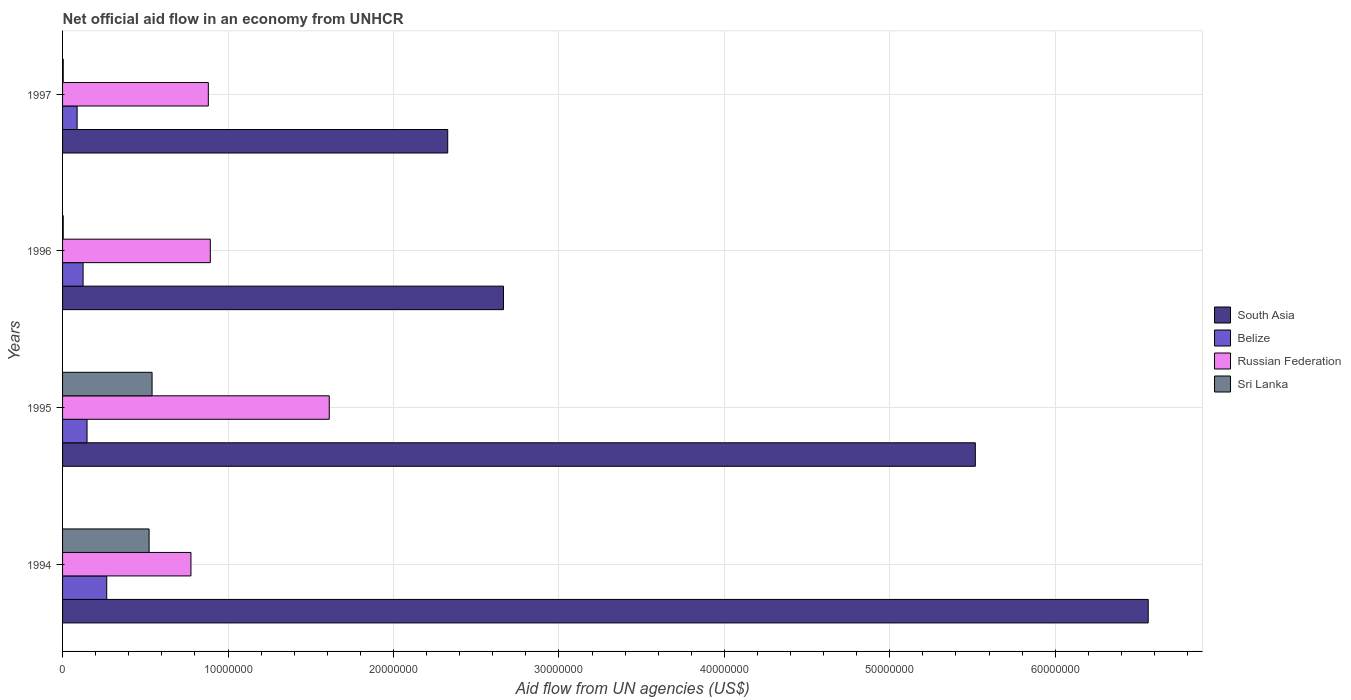How many groups of bars are there?
Your answer should be compact. 4. Are the number of bars per tick equal to the number of legend labels?
Keep it short and to the point. Yes. Are the number of bars on each tick of the Y-axis equal?
Provide a short and direct response. Yes. How many bars are there on the 3rd tick from the top?
Offer a very short reply. 4. How many bars are there on the 1st tick from the bottom?
Provide a succinct answer. 4. In how many cases, is the number of bars for a given year not equal to the number of legend labels?
Your answer should be compact. 0. What is the net official aid flow in Belize in 1995?
Your answer should be compact. 1.48e+06. Across all years, what is the maximum net official aid flow in Belize?
Make the answer very short. 2.67e+06. Across all years, what is the minimum net official aid flow in South Asia?
Provide a succinct answer. 2.33e+07. In which year was the net official aid flow in Russian Federation minimum?
Offer a terse response. 1994. What is the total net official aid flow in Russian Federation in the graph?
Offer a very short reply. 4.16e+07. What is the difference between the net official aid flow in Belize in 1994 and that in 1995?
Your answer should be very brief. 1.19e+06. What is the difference between the net official aid flow in Belize in 1994 and the net official aid flow in South Asia in 1996?
Make the answer very short. -2.40e+07. What is the average net official aid flow in Russian Federation per year?
Your response must be concise. 1.04e+07. In the year 1996, what is the difference between the net official aid flow in Sri Lanka and net official aid flow in Belize?
Offer a terse response. -1.20e+06. In how many years, is the net official aid flow in South Asia greater than 44000000 US$?
Ensure brevity in your answer.  2. What is the ratio of the net official aid flow in South Asia in 1994 to that in 1997?
Provide a succinct answer. 2.82. Is the net official aid flow in Belize in 1994 less than that in 1995?
Ensure brevity in your answer.  No. Is the difference between the net official aid flow in Sri Lanka in 1995 and 1996 greater than the difference between the net official aid flow in Belize in 1995 and 1996?
Offer a terse response. Yes. What is the difference between the highest and the second highest net official aid flow in Sri Lanka?
Give a very brief answer. 1.80e+05. What is the difference between the highest and the lowest net official aid flow in Belize?
Your answer should be very brief. 1.79e+06. In how many years, is the net official aid flow in Belize greater than the average net official aid flow in Belize taken over all years?
Your answer should be very brief. 1. What does the 4th bar from the top in 1995 represents?
Offer a very short reply. South Asia. How many bars are there?
Your response must be concise. 16. Are the values on the major ticks of X-axis written in scientific E-notation?
Provide a short and direct response. No. Does the graph contain grids?
Offer a very short reply. Yes. Where does the legend appear in the graph?
Give a very brief answer. Center right. How many legend labels are there?
Give a very brief answer. 4. How are the legend labels stacked?
Give a very brief answer. Vertical. What is the title of the graph?
Provide a short and direct response. Net official aid flow in an economy from UNHCR. Does "Iceland" appear as one of the legend labels in the graph?
Offer a terse response. No. What is the label or title of the X-axis?
Keep it short and to the point. Aid flow from UN agencies (US$). What is the label or title of the Y-axis?
Offer a very short reply. Years. What is the Aid flow from UN agencies (US$) in South Asia in 1994?
Your answer should be compact. 6.56e+07. What is the Aid flow from UN agencies (US$) in Belize in 1994?
Give a very brief answer. 2.67e+06. What is the Aid flow from UN agencies (US$) in Russian Federation in 1994?
Offer a very short reply. 7.76e+06. What is the Aid flow from UN agencies (US$) in Sri Lanka in 1994?
Your answer should be compact. 5.23e+06. What is the Aid flow from UN agencies (US$) in South Asia in 1995?
Ensure brevity in your answer.  5.52e+07. What is the Aid flow from UN agencies (US$) in Belize in 1995?
Offer a terse response. 1.48e+06. What is the Aid flow from UN agencies (US$) of Russian Federation in 1995?
Give a very brief answer. 1.61e+07. What is the Aid flow from UN agencies (US$) in Sri Lanka in 1995?
Give a very brief answer. 5.41e+06. What is the Aid flow from UN agencies (US$) in South Asia in 1996?
Give a very brief answer. 2.66e+07. What is the Aid flow from UN agencies (US$) in Belize in 1996?
Your answer should be very brief. 1.24e+06. What is the Aid flow from UN agencies (US$) in Russian Federation in 1996?
Offer a very short reply. 8.93e+06. What is the Aid flow from UN agencies (US$) in Sri Lanka in 1996?
Keep it short and to the point. 4.00e+04. What is the Aid flow from UN agencies (US$) of South Asia in 1997?
Give a very brief answer. 2.33e+07. What is the Aid flow from UN agencies (US$) in Belize in 1997?
Your answer should be very brief. 8.80e+05. What is the Aid flow from UN agencies (US$) of Russian Federation in 1997?
Your answer should be compact. 8.81e+06. What is the Aid flow from UN agencies (US$) of Sri Lanka in 1997?
Ensure brevity in your answer.  4.00e+04. Across all years, what is the maximum Aid flow from UN agencies (US$) of South Asia?
Keep it short and to the point. 6.56e+07. Across all years, what is the maximum Aid flow from UN agencies (US$) in Belize?
Your response must be concise. 2.67e+06. Across all years, what is the maximum Aid flow from UN agencies (US$) in Russian Federation?
Keep it short and to the point. 1.61e+07. Across all years, what is the maximum Aid flow from UN agencies (US$) of Sri Lanka?
Your answer should be compact. 5.41e+06. Across all years, what is the minimum Aid flow from UN agencies (US$) of South Asia?
Provide a short and direct response. 2.33e+07. Across all years, what is the minimum Aid flow from UN agencies (US$) of Belize?
Your answer should be very brief. 8.80e+05. Across all years, what is the minimum Aid flow from UN agencies (US$) in Russian Federation?
Offer a terse response. 7.76e+06. Across all years, what is the minimum Aid flow from UN agencies (US$) in Sri Lanka?
Your response must be concise. 4.00e+04. What is the total Aid flow from UN agencies (US$) of South Asia in the graph?
Ensure brevity in your answer.  1.71e+08. What is the total Aid flow from UN agencies (US$) of Belize in the graph?
Keep it short and to the point. 6.27e+06. What is the total Aid flow from UN agencies (US$) of Russian Federation in the graph?
Your response must be concise. 4.16e+07. What is the total Aid flow from UN agencies (US$) of Sri Lanka in the graph?
Provide a succinct answer. 1.07e+07. What is the difference between the Aid flow from UN agencies (US$) in South Asia in 1994 and that in 1995?
Ensure brevity in your answer.  1.04e+07. What is the difference between the Aid flow from UN agencies (US$) in Belize in 1994 and that in 1995?
Make the answer very short. 1.19e+06. What is the difference between the Aid flow from UN agencies (US$) of Russian Federation in 1994 and that in 1995?
Give a very brief answer. -8.36e+06. What is the difference between the Aid flow from UN agencies (US$) of Sri Lanka in 1994 and that in 1995?
Your answer should be very brief. -1.80e+05. What is the difference between the Aid flow from UN agencies (US$) in South Asia in 1994 and that in 1996?
Your response must be concise. 3.90e+07. What is the difference between the Aid flow from UN agencies (US$) of Belize in 1994 and that in 1996?
Your answer should be compact. 1.43e+06. What is the difference between the Aid flow from UN agencies (US$) of Russian Federation in 1994 and that in 1996?
Your answer should be compact. -1.17e+06. What is the difference between the Aid flow from UN agencies (US$) of Sri Lanka in 1994 and that in 1996?
Your answer should be compact. 5.19e+06. What is the difference between the Aid flow from UN agencies (US$) of South Asia in 1994 and that in 1997?
Ensure brevity in your answer.  4.23e+07. What is the difference between the Aid flow from UN agencies (US$) in Belize in 1994 and that in 1997?
Ensure brevity in your answer.  1.79e+06. What is the difference between the Aid flow from UN agencies (US$) of Russian Federation in 1994 and that in 1997?
Provide a short and direct response. -1.05e+06. What is the difference between the Aid flow from UN agencies (US$) in Sri Lanka in 1994 and that in 1997?
Offer a very short reply. 5.19e+06. What is the difference between the Aid flow from UN agencies (US$) of South Asia in 1995 and that in 1996?
Your answer should be very brief. 2.85e+07. What is the difference between the Aid flow from UN agencies (US$) in Belize in 1995 and that in 1996?
Your answer should be compact. 2.40e+05. What is the difference between the Aid flow from UN agencies (US$) in Russian Federation in 1995 and that in 1996?
Offer a terse response. 7.19e+06. What is the difference between the Aid flow from UN agencies (US$) in Sri Lanka in 1995 and that in 1996?
Provide a short and direct response. 5.37e+06. What is the difference between the Aid flow from UN agencies (US$) in South Asia in 1995 and that in 1997?
Offer a very short reply. 3.19e+07. What is the difference between the Aid flow from UN agencies (US$) of Belize in 1995 and that in 1997?
Provide a short and direct response. 6.00e+05. What is the difference between the Aid flow from UN agencies (US$) in Russian Federation in 1995 and that in 1997?
Your answer should be very brief. 7.31e+06. What is the difference between the Aid flow from UN agencies (US$) in Sri Lanka in 1995 and that in 1997?
Ensure brevity in your answer.  5.37e+06. What is the difference between the Aid flow from UN agencies (US$) of South Asia in 1996 and that in 1997?
Make the answer very short. 3.37e+06. What is the difference between the Aid flow from UN agencies (US$) of Russian Federation in 1996 and that in 1997?
Ensure brevity in your answer.  1.20e+05. What is the difference between the Aid flow from UN agencies (US$) in South Asia in 1994 and the Aid flow from UN agencies (US$) in Belize in 1995?
Ensure brevity in your answer.  6.41e+07. What is the difference between the Aid flow from UN agencies (US$) of South Asia in 1994 and the Aid flow from UN agencies (US$) of Russian Federation in 1995?
Your answer should be very brief. 4.95e+07. What is the difference between the Aid flow from UN agencies (US$) of South Asia in 1994 and the Aid flow from UN agencies (US$) of Sri Lanka in 1995?
Offer a very short reply. 6.02e+07. What is the difference between the Aid flow from UN agencies (US$) in Belize in 1994 and the Aid flow from UN agencies (US$) in Russian Federation in 1995?
Make the answer very short. -1.34e+07. What is the difference between the Aid flow from UN agencies (US$) of Belize in 1994 and the Aid flow from UN agencies (US$) of Sri Lanka in 1995?
Your answer should be compact. -2.74e+06. What is the difference between the Aid flow from UN agencies (US$) of Russian Federation in 1994 and the Aid flow from UN agencies (US$) of Sri Lanka in 1995?
Ensure brevity in your answer.  2.35e+06. What is the difference between the Aid flow from UN agencies (US$) in South Asia in 1994 and the Aid flow from UN agencies (US$) in Belize in 1996?
Your response must be concise. 6.44e+07. What is the difference between the Aid flow from UN agencies (US$) in South Asia in 1994 and the Aid flow from UN agencies (US$) in Russian Federation in 1996?
Offer a very short reply. 5.67e+07. What is the difference between the Aid flow from UN agencies (US$) of South Asia in 1994 and the Aid flow from UN agencies (US$) of Sri Lanka in 1996?
Offer a very short reply. 6.56e+07. What is the difference between the Aid flow from UN agencies (US$) of Belize in 1994 and the Aid flow from UN agencies (US$) of Russian Federation in 1996?
Your response must be concise. -6.26e+06. What is the difference between the Aid flow from UN agencies (US$) of Belize in 1994 and the Aid flow from UN agencies (US$) of Sri Lanka in 1996?
Provide a short and direct response. 2.63e+06. What is the difference between the Aid flow from UN agencies (US$) in Russian Federation in 1994 and the Aid flow from UN agencies (US$) in Sri Lanka in 1996?
Provide a short and direct response. 7.72e+06. What is the difference between the Aid flow from UN agencies (US$) of South Asia in 1994 and the Aid flow from UN agencies (US$) of Belize in 1997?
Give a very brief answer. 6.47e+07. What is the difference between the Aid flow from UN agencies (US$) in South Asia in 1994 and the Aid flow from UN agencies (US$) in Russian Federation in 1997?
Offer a very short reply. 5.68e+07. What is the difference between the Aid flow from UN agencies (US$) of South Asia in 1994 and the Aid flow from UN agencies (US$) of Sri Lanka in 1997?
Make the answer very short. 6.56e+07. What is the difference between the Aid flow from UN agencies (US$) of Belize in 1994 and the Aid flow from UN agencies (US$) of Russian Federation in 1997?
Your answer should be very brief. -6.14e+06. What is the difference between the Aid flow from UN agencies (US$) of Belize in 1994 and the Aid flow from UN agencies (US$) of Sri Lanka in 1997?
Keep it short and to the point. 2.63e+06. What is the difference between the Aid flow from UN agencies (US$) in Russian Federation in 1994 and the Aid flow from UN agencies (US$) in Sri Lanka in 1997?
Make the answer very short. 7.72e+06. What is the difference between the Aid flow from UN agencies (US$) in South Asia in 1995 and the Aid flow from UN agencies (US$) in Belize in 1996?
Ensure brevity in your answer.  5.39e+07. What is the difference between the Aid flow from UN agencies (US$) of South Asia in 1995 and the Aid flow from UN agencies (US$) of Russian Federation in 1996?
Give a very brief answer. 4.62e+07. What is the difference between the Aid flow from UN agencies (US$) of South Asia in 1995 and the Aid flow from UN agencies (US$) of Sri Lanka in 1996?
Offer a very short reply. 5.51e+07. What is the difference between the Aid flow from UN agencies (US$) of Belize in 1995 and the Aid flow from UN agencies (US$) of Russian Federation in 1996?
Ensure brevity in your answer.  -7.45e+06. What is the difference between the Aid flow from UN agencies (US$) in Belize in 1995 and the Aid flow from UN agencies (US$) in Sri Lanka in 1996?
Make the answer very short. 1.44e+06. What is the difference between the Aid flow from UN agencies (US$) of Russian Federation in 1995 and the Aid flow from UN agencies (US$) of Sri Lanka in 1996?
Ensure brevity in your answer.  1.61e+07. What is the difference between the Aid flow from UN agencies (US$) in South Asia in 1995 and the Aid flow from UN agencies (US$) in Belize in 1997?
Make the answer very short. 5.43e+07. What is the difference between the Aid flow from UN agencies (US$) of South Asia in 1995 and the Aid flow from UN agencies (US$) of Russian Federation in 1997?
Your response must be concise. 4.64e+07. What is the difference between the Aid flow from UN agencies (US$) in South Asia in 1995 and the Aid flow from UN agencies (US$) in Sri Lanka in 1997?
Your response must be concise. 5.51e+07. What is the difference between the Aid flow from UN agencies (US$) in Belize in 1995 and the Aid flow from UN agencies (US$) in Russian Federation in 1997?
Your response must be concise. -7.33e+06. What is the difference between the Aid flow from UN agencies (US$) in Belize in 1995 and the Aid flow from UN agencies (US$) in Sri Lanka in 1997?
Make the answer very short. 1.44e+06. What is the difference between the Aid flow from UN agencies (US$) of Russian Federation in 1995 and the Aid flow from UN agencies (US$) of Sri Lanka in 1997?
Offer a terse response. 1.61e+07. What is the difference between the Aid flow from UN agencies (US$) in South Asia in 1996 and the Aid flow from UN agencies (US$) in Belize in 1997?
Give a very brief answer. 2.58e+07. What is the difference between the Aid flow from UN agencies (US$) of South Asia in 1996 and the Aid flow from UN agencies (US$) of Russian Federation in 1997?
Make the answer very short. 1.78e+07. What is the difference between the Aid flow from UN agencies (US$) in South Asia in 1996 and the Aid flow from UN agencies (US$) in Sri Lanka in 1997?
Your answer should be very brief. 2.66e+07. What is the difference between the Aid flow from UN agencies (US$) in Belize in 1996 and the Aid flow from UN agencies (US$) in Russian Federation in 1997?
Keep it short and to the point. -7.57e+06. What is the difference between the Aid flow from UN agencies (US$) in Belize in 1996 and the Aid flow from UN agencies (US$) in Sri Lanka in 1997?
Your response must be concise. 1.20e+06. What is the difference between the Aid flow from UN agencies (US$) of Russian Federation in 1996 and the Aid flow from UN agencies (US$) of Sri Lanka in 1997?
Provide a short and direct response. 8.89e+06. What is the average Aid flow from UN agencies (US$) of South Asia per year?
Offer a very short reply. 4.27e+07. What is the average Aid flow from UN agencies (US$) in Belize per year?
Your answer should be compact. 1.57e+06. What is the average Aid flow from UN agencies (US$) in Russian Federation per year?
Provide a succinct answer. 1.04e+07. What is the average Aid flow from UN agencies (US$) in Sri Lanka per year?
Make the answer very short. 2.68e+06. In the year 1994, what is the difference between the Aid flow from UN agencies (US$) in South Asia and Aid flow from UN agencies (US$) in Belize?
Provide a succinct answer. 6.30e+07. In the year 1994, what is the difference between the Aid flow from UN agencies (US$) of South Asia and Aid flow from UN agencies (US$) of Russian Federation?
Offer a very short reply. 5.79e+07. In the year 1994, what is the difference between the Aid flow from UN agencies (US$) in South Asia and Aid flow from UN agencies (US$) in Sri Lanka?
Offer a terse response. 6.04e+07. In the year 1994, what is the difference between the Aid flow from UN agencies (US$) of Belize and Aid flow from UN agencies (US$) of Russian Federation?
Offer a very short reply. -5.09e+06. In the year 1994, what is the difference between the Aid flow from UN agencies (US$) of Belize and Aid flow from UN agencies (US$) of Sri Lanka?
Offer a terse response. -2.56e+06. In the year 1994, what is the difference between the Aid flow from UN agencies (US$) in Russian Federation and Aid flow from UN agencies (US$) in Sri Lanka?
Make the answer very short. 2.53e+06. In the year 1995, what is the difference between the Aid flow from UN agencies (US$) in South Asia and Aid flow from UN agencies (US$) in Belize?
Keep it short and to the point. 5.37e+07. In the year 1995, what is the difference between the Aid flow from UN agencies (US$) in South Asia and Aid flow from UN agencies (US$) in Russian Federation?
Keep it short and to the point. 3.90e+07. In the year 1995, what is the difference between the Aid flow from UN agencies (US$) in South Asia and Aid flow from UN agencies (US$) in Sri Lanka?
Offer a terse response. 4.98e+07. In the year 1995, what is the difference between the Aid flow from UN agencies (US$) of Belize and Aid flow from UN agencies (US$) of Russian Federation?
Give a very brief answer. -1.46e+07. In the year 1995, what is the difference between the Aid flow from UN agencies (US$) in Belize and Aid flow from UN agencies (US$) in Sri Lanka?
Your answer should be compact. -3.93e+06. In the year 1995, what is the difference between the Aid flow from UN agencies (US$) of Russian Federation and Aid flow from UN agencies (US$) of Sri Lanka?
Keep it short and to the point. 1.07e+07. In the year 1996, what is the difference between the Aid flow from UN agencies (US$) in South Asia and Aid flow from UN agencies (US$) in Belize?
Your answer should be compact. 2.54e+07. In the year 1996, what is the difference between the Aid flow from UN agencies (US$) of South Asia and Aid flow from UN agencies (US$) of Russian Federation?
Your answer should be compact. 1.77e+07. In the year 1996, what is the difference between the Aid flow from UN agencies (US$) in South Asia and Aid flow from UN agencies (US$) in Sri Lanka?
Provide a succinct answer. 2.66e+07. In the year 1996, what is the difference between the Aid flow from UN agencies (US$) in Belize and Aid flow from UN agencies (US$) in Russian Federation?
Give a very brief answer. -7.69e+06. In the year 1996, what is the difference between the Aid flow from UN agencies (US$) of Belize and Aid flow from UN agencies (US$) of Sri Lanka?
Provide a short and direct response. 1.20e+06. In the year 1996, what is the difference between the Aid flow from UN agencies (US$) of Russian Federation and Aid flow from UN agencies (US$) of Sri Lanka?
Your answer should be very brief. 8.89e+06. In the year 1997, what is the difference between the Aid flow from UN agencies (US$) of South Asia and Aid flow from UN agencies (US$) of Belize?
Your answer should be compact. 2.24e+07. In the year 1997, what is the difference between the Aid flow from UN agencies (US$) in South Asia and Aid flow from UN agencies (US$) in Russian Federation?
Your answer should be compact. 1.45e+07. In the year 1997, what is the difference between the Aid flow from UN agencies (US$) of South Asia and Aid flow from UN agencies (US$) of Sri Lanka?
Your answer should be compact. 2.32e+07. In the year 1997, what is the difference between the Aid flow from UN agencies (US$) of Belize and Aid flow from UN agencies (US$) of Russian Federation?
Make the answer very short. -7.93e+06. In the year 1997, what is the difference between the Aid flow from UN agencies (US$) of Belize and Aid flow from UN agencies (US$) of Sri Lanka?
Keep it short and to the point. 8.40e+05. In the year 1997, what is the difference between the Aid flow from UN agencies (US$) in Russian Federation and Aid flow from UN agencies (US$) in Sri Lanka?
Make the answer very short. 8.77e+06. What is the ratio of the Aid flow from UN agencies (US$) in South Asia in 1994 to that in 1995?
Your response must be concise. 1.19. What is the ratio of the Aid flow from UN agencies (US$) in Belize in 1994 to that in 1995?
Your answer should be compact. 1.8. What is the ratio of the Aid flow from UN agencies (US$) in Russian Federation in 1994 to that in 1995?
Give a very brief answer. 0.48. What is the ratio of the Aid flow from UN agencies (US$) in Sri Lanka in 1994 to that in 1995?
Offer a very short reply. 0.97. What is the ratio of the Aid flow from UN agencies (US$) in South Asia in 1994 to that in 1996?
Your answer should be very brief. 2.46. What is the ratio of the Aid flow from UN agencies (US$) of Belize in 1994 to that in 1996?
Offer a terse response. 2.15. What is the ratio of the Aid flow from UN agencies (US$) of Russian Federation in 1994 to that in 1996?
Offer a very short reply. 0.87. What is the ratio of the Aid flow from UN agencies (US$) of Sri Lanka in 1994 to that in 1996?
Make the answer very short. 130.75. What is the ratio of the Aid flow from UN agencies (US$) in South Asia in 1994 to that in 1997?
Provide a succinct answer. 2.82. What is the ratio of the Aid flow from UN agencies (US$) of Belize in 1994 to that in 1997?
Your answer should be very brief. 3.03. What is the ratio of the Aid flow from UN agencies (US$) of Russian Federation in 1994 to that in 1997?
Offer a very short reply. 0.88. What is the ratio of the Aid flow from UN agencies (US$) in Sri Lanka in 1994 to that in 1997?
Ensure brevity in your answer.  130.75. What is the ratio of the Aid flow from UN agencies (US$) of South Asia in 1995 to that in 1996?
Ensure brevity in your answer.  2.07. What is the ratio of the Aid flow from UN agencies (US$) in Belize in 1995 to that in 1996?
Provide a succinct answer. 1.19. What is the ratio of the Aid flow from UN agencies (US$) of Russian Federation in 1995 to that in 1996?
Your response must be concise. 1.81. What is the ratio of the Aid flow from UN agencies (US$) in Sri Lanka in 1995 to that in 1996?
Keep it short and to the point. 135.25. What is the ratio of the Aid flow from UN agencies (US$) of South Asia in 1995 to that in 1997?
Keep it short and to the point. 2.37. What is the ratio of the Aid flow from UN agencies (US$) in Belize in 1995 to that in 1997?
Provide a succinct answer. 1.68. What is the ratio of the Aid flow from UN agencies (US$) in Russian Federation in 1995 to that in 1997?
Offer a very short reply. 1.83. What is the ratio of the Aid flow from UN agencies (US$) of Sri Lanka in 1995 to that in 1997?
Keep it short and to the point. 135.25. What is the ratio of the Aid flow from UN agencies (US$) of South Asia in 1996 to that in 1997?
Keep it short and to the point. 1.14. What is the ratio of the Aid flow from UN agencies (US$) in Belize in 1996 to that in 1997?
Make the answer very short. 1.41. What is the ratio of the Aid flow from UN agencies (US$) of Russian Federation in 1996 to that in 1997?
Ensure brevity in your answer.  1.01. What is the ratio of the Aid flow from UN agencies (US$) of Sri Lanka in 1996 to that in 1997?
Offer a very short reply. 1. What is the difference between the highest and the second highest Aid flow from UN agencies (US$) in South Asia?
Your response must be concise. 1.04e+07. What is the difference between the highest and the second highest Aid flow from UN agencies (US$) of Belize?
Your answer should be very brief. 1.19e+06. What is the difference between the highest and the second highest Aid flow from UN agencies (US$) of Russian Federation?
Make the answer very short. 7.19e+06. What is the difference between the highest and the second highest Aid flow from UN agencies (US$) of Sri Lanka?
Make the answer very short. 1.80e+05. What is the difference between the highest and the lowest Aid flow from UN agencies (US$) in South Asia?
Your response must be concise. 4.23e+07. What is the difference between the highest and the lowest Aid flow from UN agencies (US$) in Belize?
Keep it short and to the point. 1.79e+06. What is the difference between the highest and the lowest Aid flow from UN agencies (US$) in Russian Federation?
Keep it short and to the point. 8.36e+06. What is the difference between the highest and the lowest Aid flow from UN agencies (US$) in Sri Lanka?
Give a very brief answer. 5.37e+06. 